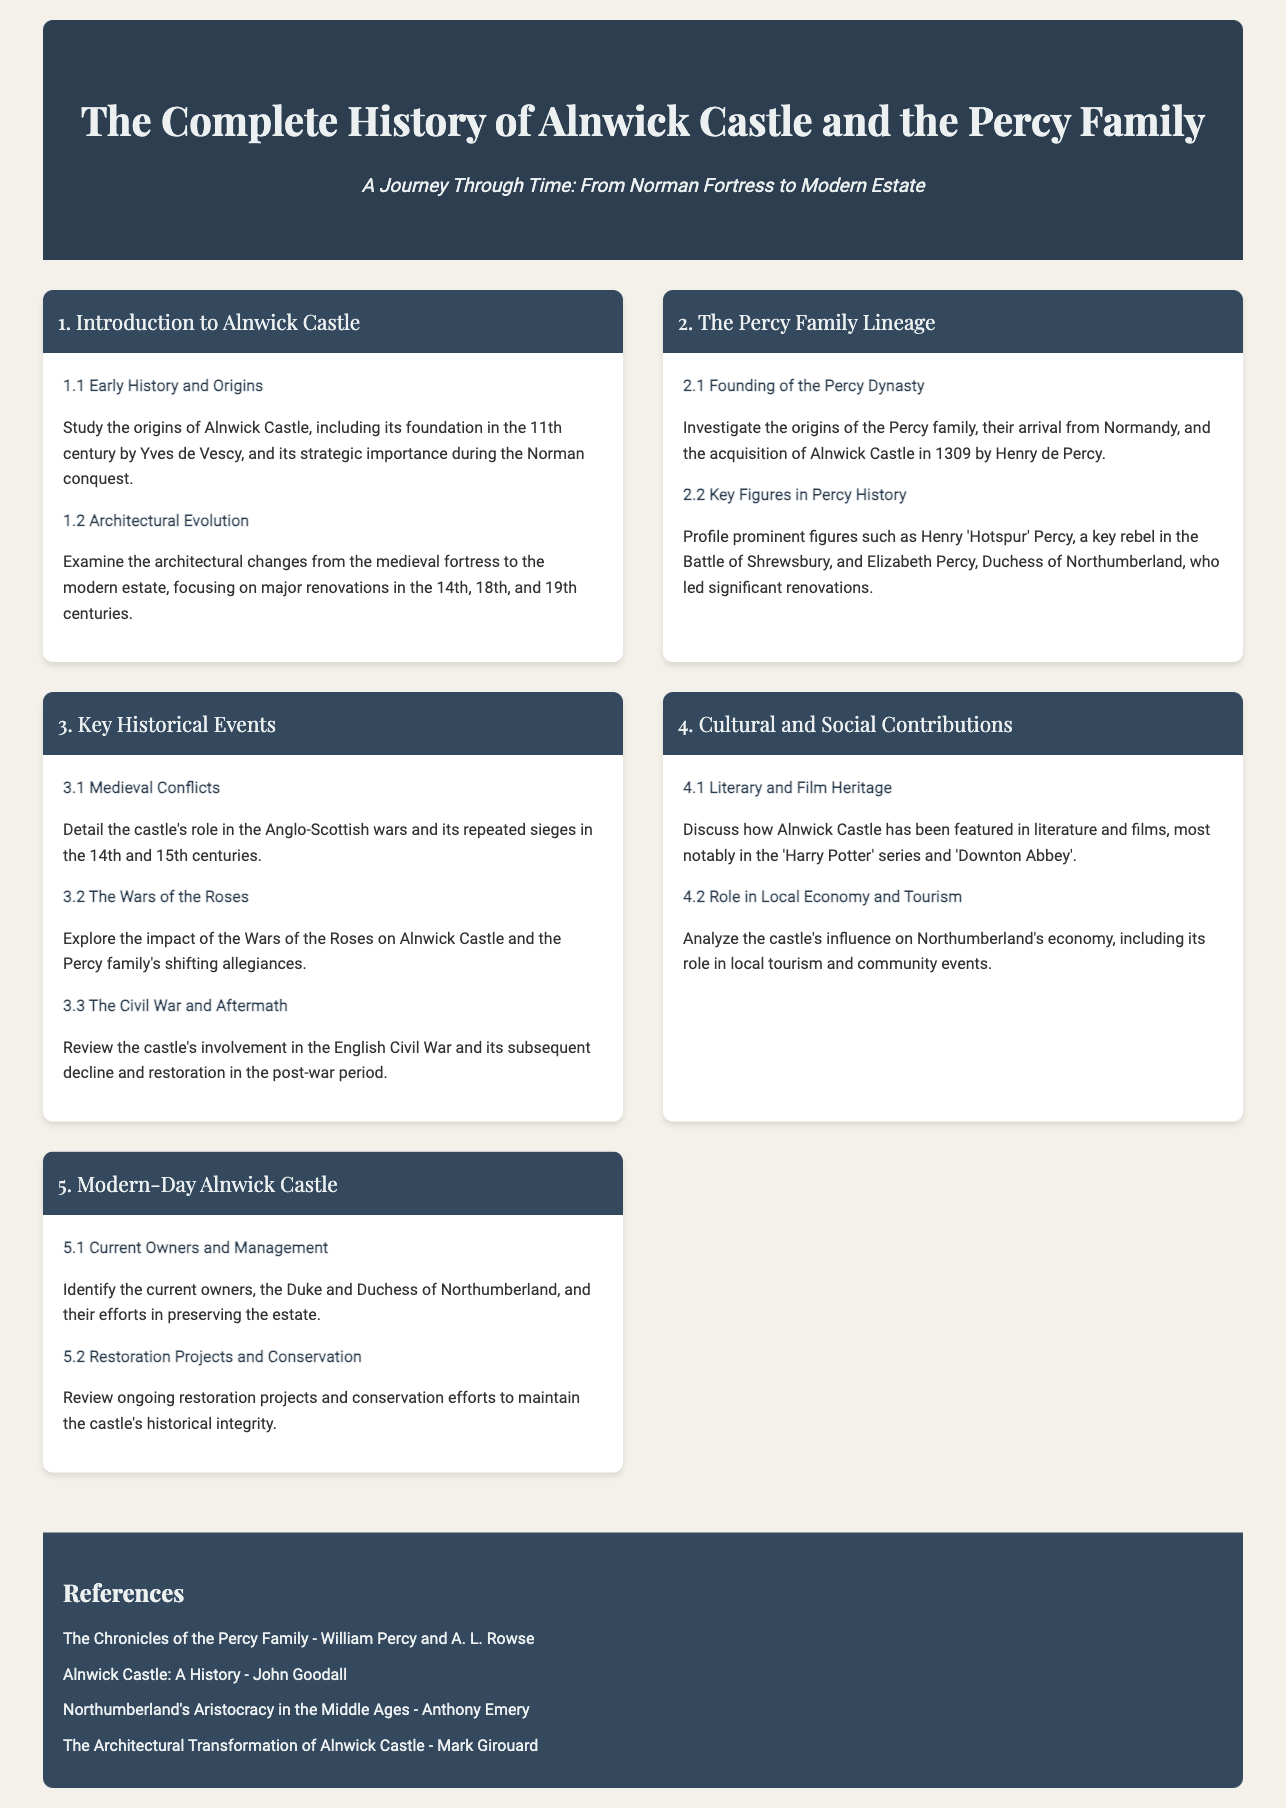What year was Alnwick Castle founded? The document states that Alnwick Castle was founded in the 11th century, specifically mentioning its foundation period.
Answer: 11th century Who founded the Percy dynasty? The syllabus indicates that the origins of the Percy family are traced back to their arrival from Normandy and their acquisition of Alnwick Castle.
Answer: Henry de Percy Which castle was a significant location during the Anglo-Scottish wars? The document discusses Alnwick Castle's role in the Anglo-Scottish wars.
Answer: Alnwick Castle In which battle was Henry 'Hotspur' Percy a key rebel? The syllabus highlights that he was involved in the Battle of Shrewsbury.
Answer: Battle of Shrewsbury What is a notable modern appearance of Alnwick Castle? The document mentions that Alnwick Castle has featured in the 'Harry Potter' series.
Answer: Harry Potter Who are the current owners of Alnwick Castle? The syllabus specifies the current owners as the Duke and Duchess of Northumberland.
Answer: Duke and Duchess of Northumberland When did significant renovations occur in Alnwick Castle? The document notes major renovations in the 14th, 18th, and 19th centuries.
Answer: 14th, 18th, and 19th centuries What type of contributions does Alnwick Castle have in Northumberland? The syllabus indicates the castle's influence on the local economy and tourism as a significant contribution.
Answer: Local economy and tourism What major conflict influenced the Percy family's allegiances? The document refers to the Wars of the Roses and its impact on the family.
Answer: Wars of the Roses 